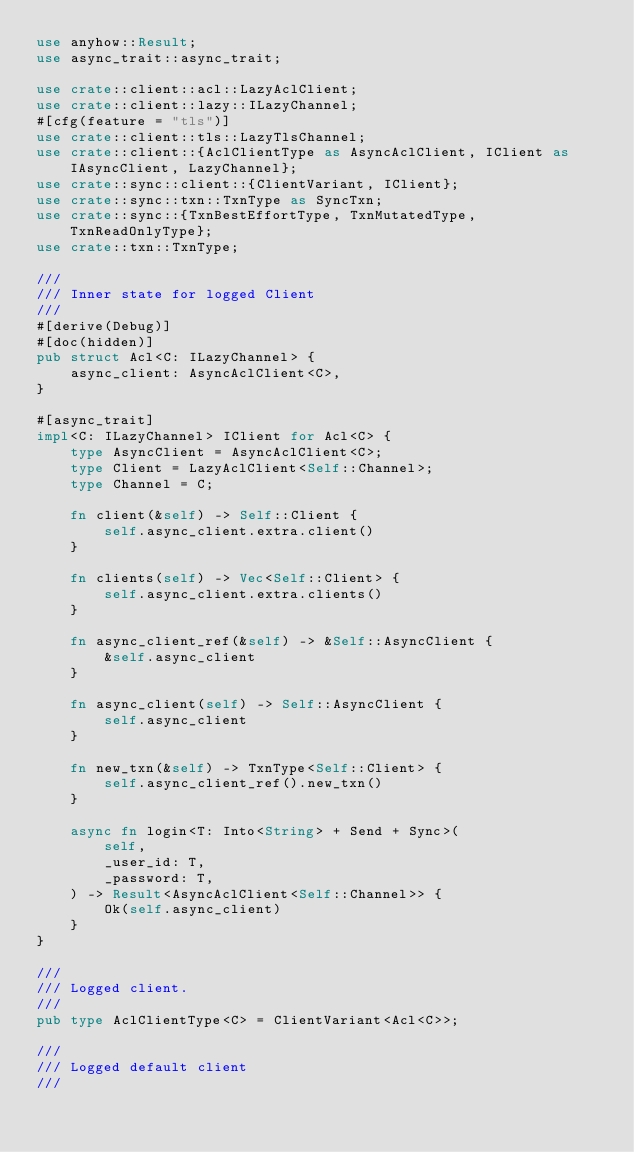Convert code to text. <code><loc_0><loc_0><loc_500><loc_500><_Rust_>use anyhow::Result;
use async_trait::async_trait;

use crate::client::acl::LazyAclClient;
use crate::client::lazy::ILazyChannel;
#[cfg(feature = "tls")]
use crate::client::tls::LazyTlsChannel;
use crate::client::{AclClientType as AsyncAclClient, IClient as IAsyncClient, LazyChannel};
use crate::sync::client::{ClientVariant, IClient};
use crate::sync::txn::TxnType as SyncTxn;
use crate::sync::{TxnBestEffortType, TxnMutatedType, TxnReadOnlyType};
use crate::txn::TxnType;

///
/// Inner state for logged Client
///
#[derive(Debug)]
#[doc(hidden)]
pub struct Acl<C: ILazyChannel> {
    async_client: AsyncAclClient<C>,
}

#[async_trait]
impl<C: ILazyChannel> IClient for Acl<C> {
    type AsyncClient = AsyncAclClient<C>;
    type Client = LazyAclClient<Self::Channel>;
    type Channel = C;

    fn client(&self) -> Self::Client {
        self.async_client.extra.client()
    }

    fn clients(self) -> Vec<Self::Client> {
        self.async_client.extra.clients()
    }

    fn async_client_ref(&self) -> &Self::AsyncClient {
        &self.async_client
    }

    fn async_client(self) -> Self::AsyncClient {
        self.async_client
    }

    fn new_txn(&self) -> TxnType<Self::Client> {
        self.async_client_ref().new_txn()
    }

    async fn login<T: Into<String> + Send + Sync>(
        self,
        _user_id: T,
        _password: T,
    ) -> Result<AsyncAclClient<Self::Channel>> {
        Ok(self.async_client)
    }
}

///
/// Logged client.
///
pub type AclClientType<C> = ClientVariant<Acl<C>>;

///
/// Logged default client
///</code> 